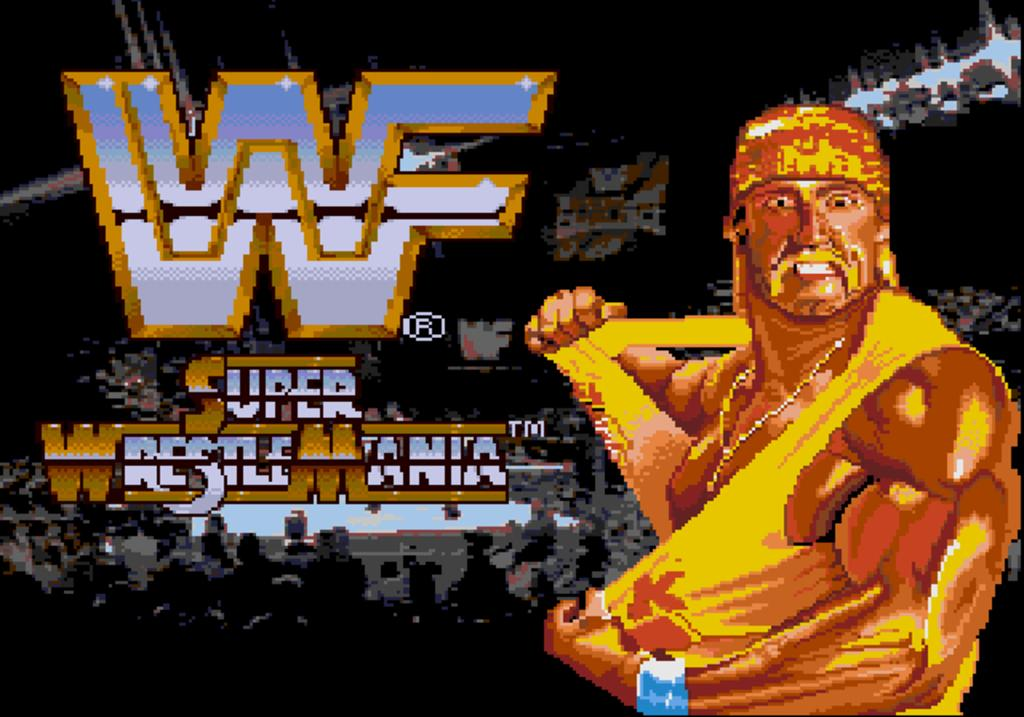What type of image is being described? The image is animated. Can you describe the main subject in the image? There is a person in the image. Are there any words or letters visible in the image? Yes, there is writing on the image. What type of sack is being carried by the person in the image? There is no sack visible in the image; only a person and writing are present. What message does the peace sign convey in the image? There is no peace sign present in the image; it only contains a person and writing. 